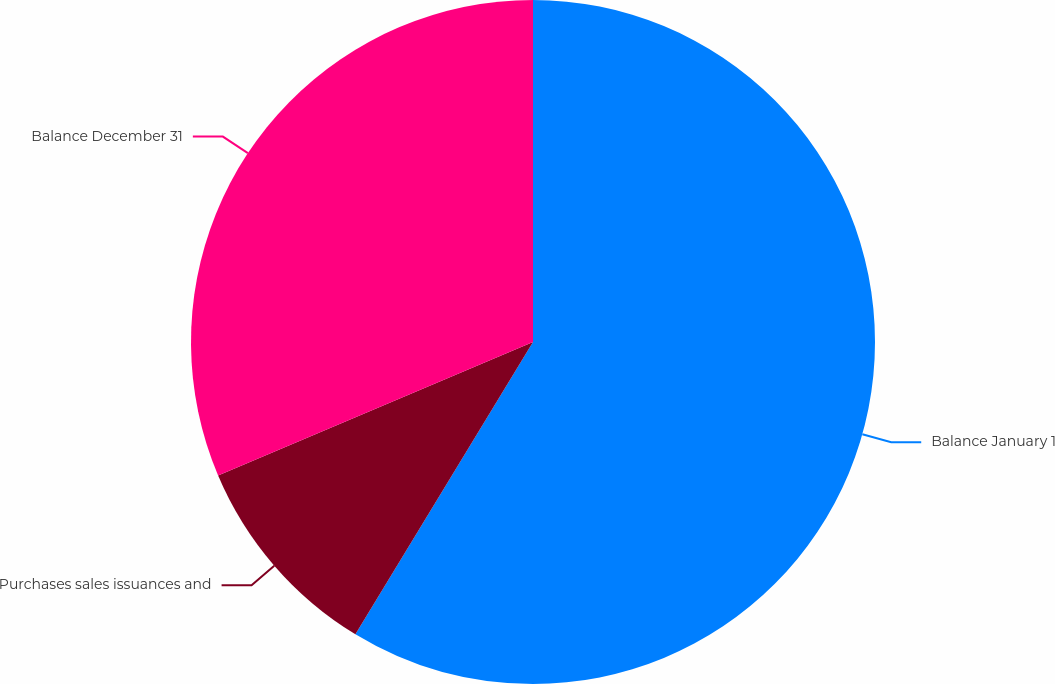Convert chart to OTSL. <chart><loc_0><loc_0><loc_500><loc_500><pie_chart><fcel>Balance January 1<fcel>Purchases sales issuances and<fcel>Balance December 31<nl><fcel>58.69%<fcel>9.93%<fcel>31.38%<nl></chart> 